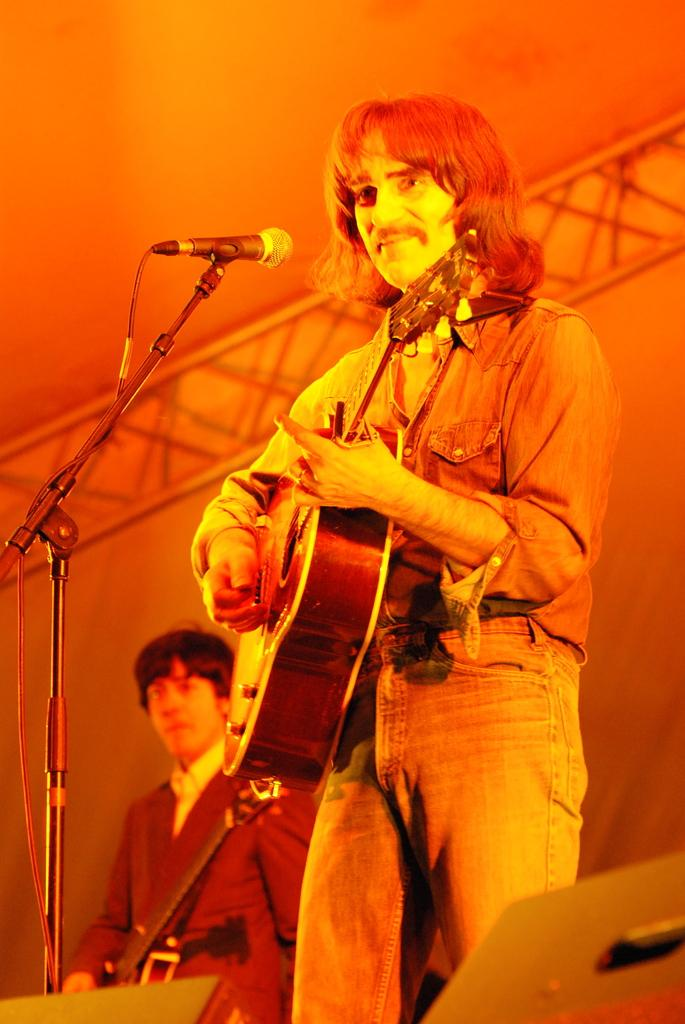What is the man in the image holding? The man in the image is holding a guitar. What is in front of the man holding the guitar? There is a microphone with a stand in front of the man holding the guitar. Is there anyone else in the image besides the man holding the guitar? Yes, there is another man standing beside the man holding the guitar. How many pancakes are on the guitar in the image? There are no pancakes present in the image, as it features a man holding a guitar and a microphone with a stand. 